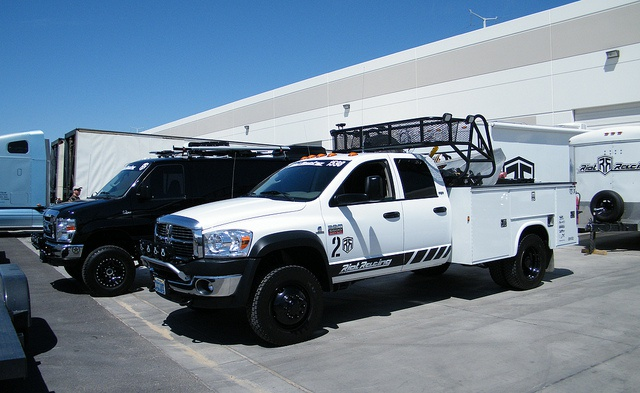Describe the objects in this image and their specific colors. I can see truck in gray, black, lightgray, darkgray, and lightblue tones, truck in gray, black, blue, and navy tones, truck in gray, lightgray, and black tones, and people in gray, black, and lightgray tones in this image. 